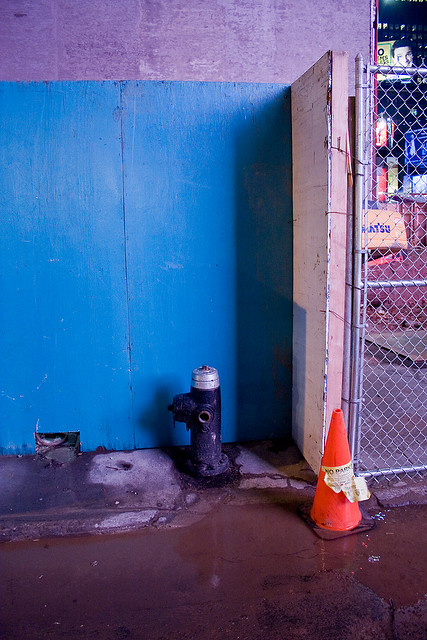Identify the text displayed in this image. No Parking 